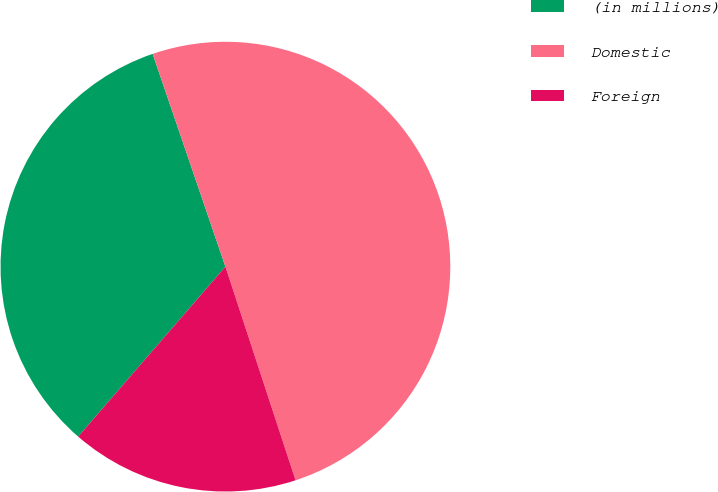<chart> <loc_0><loc_0><loc_500><loc_500><pie_chart><fcel>(in millions)<fcel>Domestic<fcel>Foreign<nl><fcel>33.39%<fcel>50.19%<fcel>16.41%<nl></chart> 